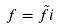<formula> <loc_0><loc_0><loc_500><loc_500>f = \tilde { f } i</formula> 